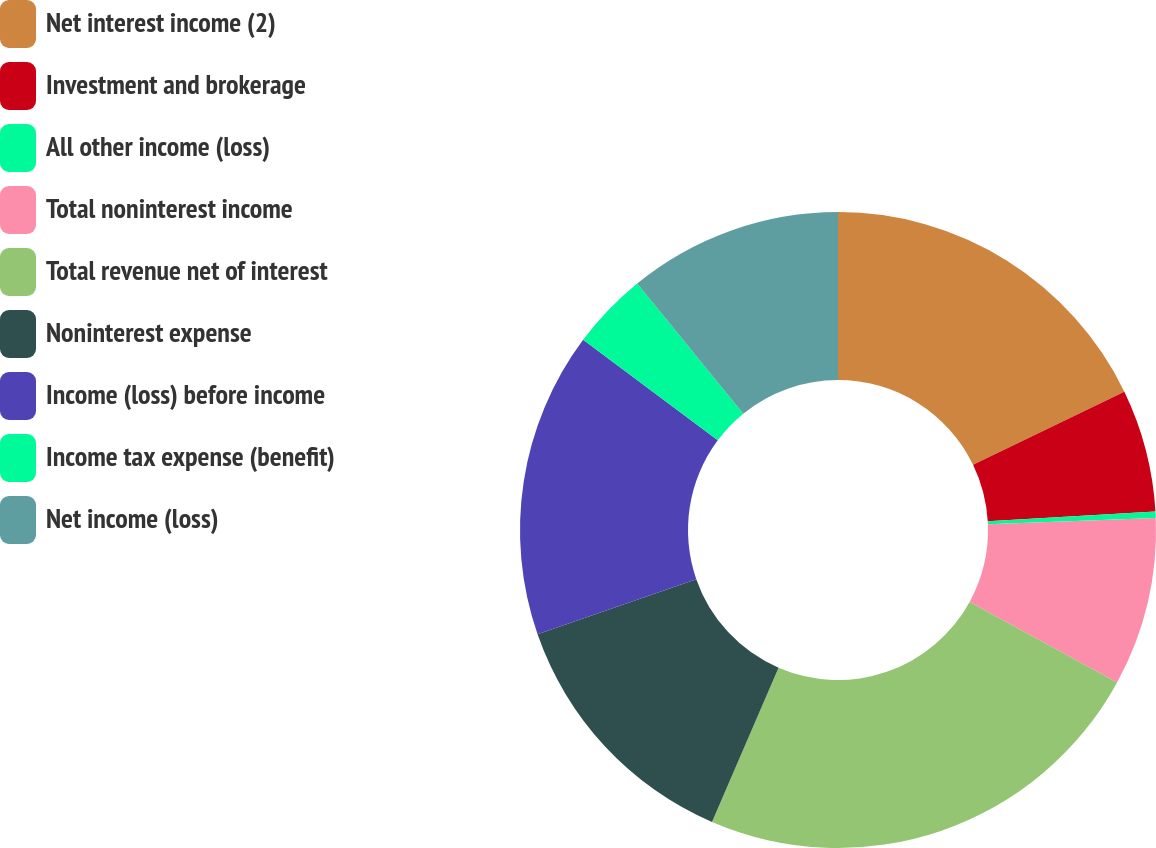Convert chart to OTSL. <chart><loc_0><loc_0><loc_500><loc_500><pie_chart><fcel>Net interest income (2)<fcel>Investment and brokerage<fcel>All other income (loss)<fcel>Total noninterest income<fcel>Total revenue net of interest<fcel>Noninterest expense<fcel>Income (loss) before income<fcel>Income tax expense (benefit)<fcel>Net income (loss)<nl><fcel>17.84%<fcel>6.24%<fcel>0.32%<fcel>8.56%<fcel>23.53%<fcel>13.2%<fcel>15.52%<fcel>3.92%<fcel>10.88%<nl></chart> 